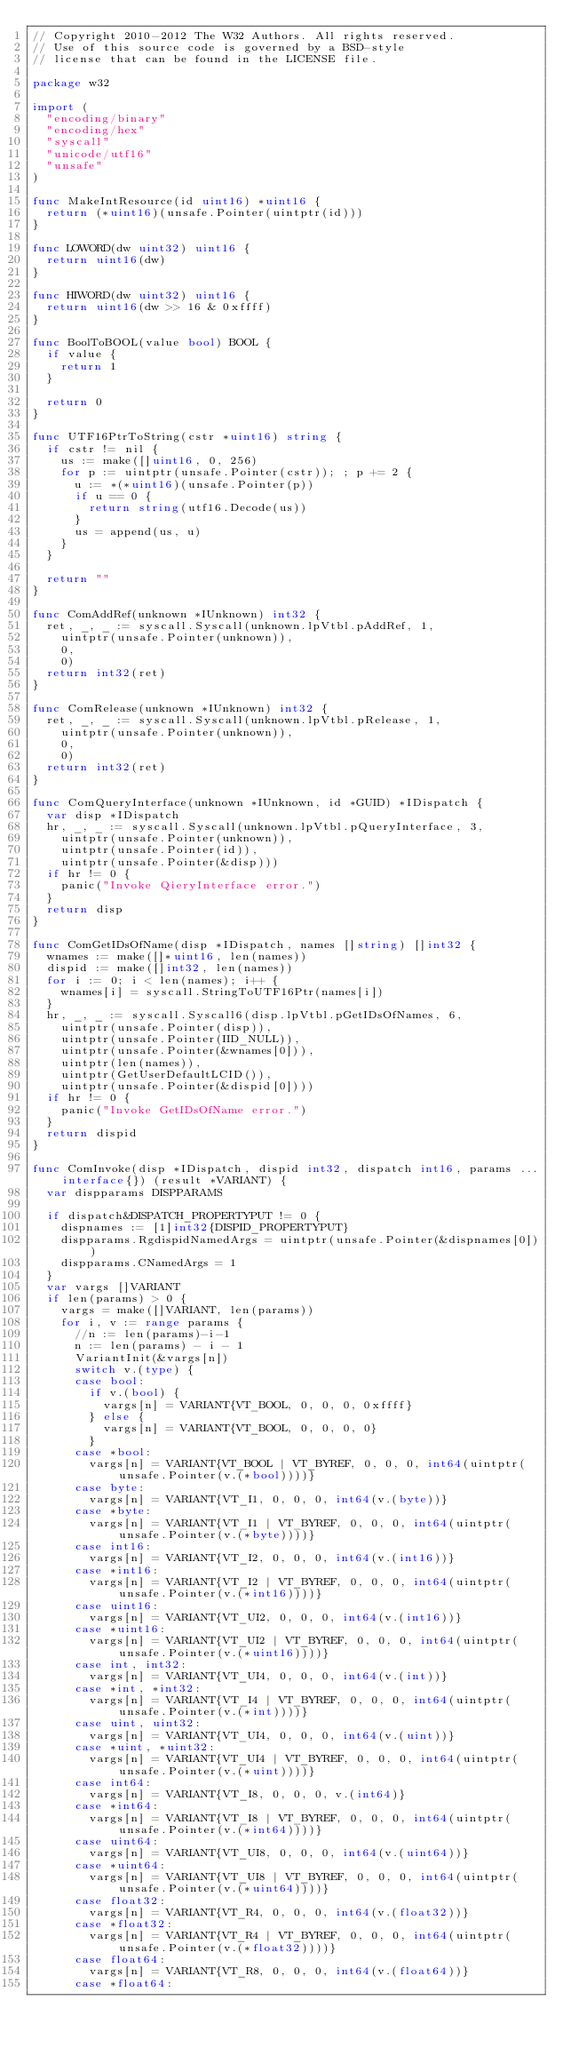<code> <loc_0><loc_0><loc_500><loc_500><_Go_>// Copyright 2010-2012 The W32 Authors. All rights reserved.
// Use of this source code is governed by a BSD-style
// license that can be found in the LICENSE file.

package w32

import (
	"encoding/binary"
	"encoding/hex"
	"syscall"
	"unicode/utf16"
	"unsafe"
)

func MakeIntResource(id uint16) *uint16 {
	return (*uint16)(unsafe.Pointer(uintptr(id)))
}

func LOWORD(dw uint32) uint16 {
	return uint16(dw)
}

func HIWORD(dw uint32) uint16 {
	return uint16(dw >> 16 & 0xffff)
}

func BoolToBOOL(value bool) BOOL {
	if value {
		return 1
	}

	return 0
}

func UTF16PtrToString(cstr *uint16) string {
	if cstr != nil {
		us := make([]uint16, 0, 256)
		for p := uintptr(unsafe.Pointer(cstr)); ; p += 2 {
			u := *(*uint16)(unsafe.Pointer(p))
			if u == 0 {
				return string(utf16.Decode(us))
			}
			us = append(us, u)
		}
	}

	return ""
}

func ComAddRef(unknown *IUnknown) int32 {
	ret, _, _ := syscall.Syscall(unknown.lpVtbl.pAddRef, 1,
		uintptr(unsafe.Pointer(unknown)),
		0,
		0)
	return int32(ret)
}

func ComRelease(unknown *IUnknown) int32 {
	ret, _, _ := syscall.Syscall(unknown.lpVtbl.pRelease, 1,
		uintptr(unsafe.Pointer(unknown)),
		0,
		0)
	return int32(ret)
}

func ComQueryInterface(unknown *IUnknown, id *GUID) *IDispatch {
	var disp *IDispatch
	hr, _, _ := syscall.Syscall(unknown.lpVtbl.pQueryInterface, 3,
		uintptr(unsafe.Pointer(unknown)),
		uintptr(unsafe.Pointer(id)),
		uintptr(unsafe.Pointer(&disp)))
	if hr != 0 {
		panic("Invoke QieryInterface error.")
	}
	return disp
}

func ComGetIDsOfName(disp *IDispatch, names []string) []int32 {
	wnames := make([]*uint16, len(names))
	dispid := make([]int32, len(names))
	for i := 0; i < len(names); i++ {
		wnames[i] = syscall.StringToUTF16Ptr(names[i])
	}
	hr, _, _ := syscall.Syscall6(disp.lpVtbl.pGetIDsOfNames, 6,
		uintptr(unsafe.Pointer(disp)),
		uintptr(unsafe.Pointer(IID_NULL)),
		uintptr(unsafe.Pointer(&wnames[0])),
		uintptr(len(names)),
		uintptr(GetUserDefaultLCID()),
		uintptr(unsafe.Pointer(&dispid[0])))
	if hr != 0 {
		panic("Invoke GetIDsOfName error.")
	}
	return dispid
}

func ComInvoke(disp *IDispatch, dispid int32, dispatch int16, params ...interface{}) (result *VARIANT) {
	var dispparams DISPPARAMS

	if dispatch&DISPATCH_PROPERTYPUT != 0 {
		dispnames := [1]int32{DISPID_PROPERTYPUT}
		dispparams.RgdispidNamedArgs = uintptr(unsafe.Pointer(&dispnames[0]))
		dispparams.CNamedArgs = 1
	}
	var vargs []VARIANT
	if len(params) > 0 {
		vargs = make([]VARIANT, len(params))
		for i, v := range params {
			//n := len(params)-i-1
			n := len(params) - i - 1
			VariantInit(&vargs[n])
			switch v.(type) {
			case bool:
				if v.(bool) {
					vargs[n] = VARIANT{VT_BOOL, 0, 0, 0, 0xffff}
				} else {
					vargs[n] = VARIANT{VT_BOOL, 0, 0, 0, 0}
				}
			case *bool:
				vargs[n] = VARIANT{VT_BOOL | VT_BYREF, 0, 0, 0, int64(uintptr(unsafe.Pointer(v.(*bool))))}
			case byte:
				vargs[n] = VARIANT{VT_I1, 0, 0, 0, int64(v.(byte))}
			case *byte:
				vargs[n] = VARIANT{VT_I1 | VT_BYREF, 0, 0, 0, int64(uintptr(unsafe.Pointer(v.(*byte))))}
			case int16:
				vargs[n] = VARIANT{VT_I2, 0, 0, 0, int64(v.(int16))}
			case *int16:
				vargs[n] = VARIANT{VT_I2 | VT_BYREF, 0, 0, 0, int64(uintptr(unsafe.Pointer(v.(*int16))))}
			case uint16:
				vargs[n] = VARIANT{VT_UI2, 0, 0, 0, int64(v.(int16))}
			case *uint16:
				vargs[n] = VARIANT{VT_UI2 | VT_BYREF, 0, 0, 0, int64(uintptr(unsafe.Pointer(v.(*uint16))))}
			case int, int32:
				vargs[n] = VARIANT{VT_UI4, 0, 0, 0, int64(v.(int))}
			case *int, *int32:
				vargs[n] = VARIANT{VT_I4 | VT_BYREF, 0, 0, 0, int64(uintptr(unsafe.Pointer(v.(*int))))}
			case uint, uint32:
				vargs[n] = VARIANT{VT_UI4, 0, 0, 0, int64(v.(uint))}
			case *uint, *uint32:
				vargs[n] = VARIANT{VT_UI4 | VT_BYREF, 0, 0, 0, int64(uintptr(unsafe.Pointer(v.(*uint))))}
			case int64:
				vargs[n] = VARIANT{VT_I8, 0, 0, 0, v.(int64)}
			case *int64:
				vargs[n] = VARIANT{VT_I8 | VT_BYREF, 0, 0, 0, int64(uintptr(unsafe.Pointer(v.(*int64))))}
			case uint64:
				vargs[n] = VARIANT{VT_UI8, 0, 0, 0, int64(v.(uint64))}
			case *uint64:
				vargs[n] = VARIANT{VT_UI8 | VT_BYREF, 0, 0, 0, int64(uintptr(unsafe.Pointer(v.(*uint64))))}
			case float32:
				vargs[n] = VARIANT{VT_R4, 0, 0, 0, int64(v.(float32))}
			case *float32:
				vargs[n] = VARIANT{VT_R4 | VT_BYREF, 0, 0, 0, int64(uintptr(unsafe.Pointer(v.(*float32))))}
			case float64:
				vargs[n] = VARIANT{VT_R8, 0, 0, 0, int64(v.(float64))}
			case *float64:</code> 